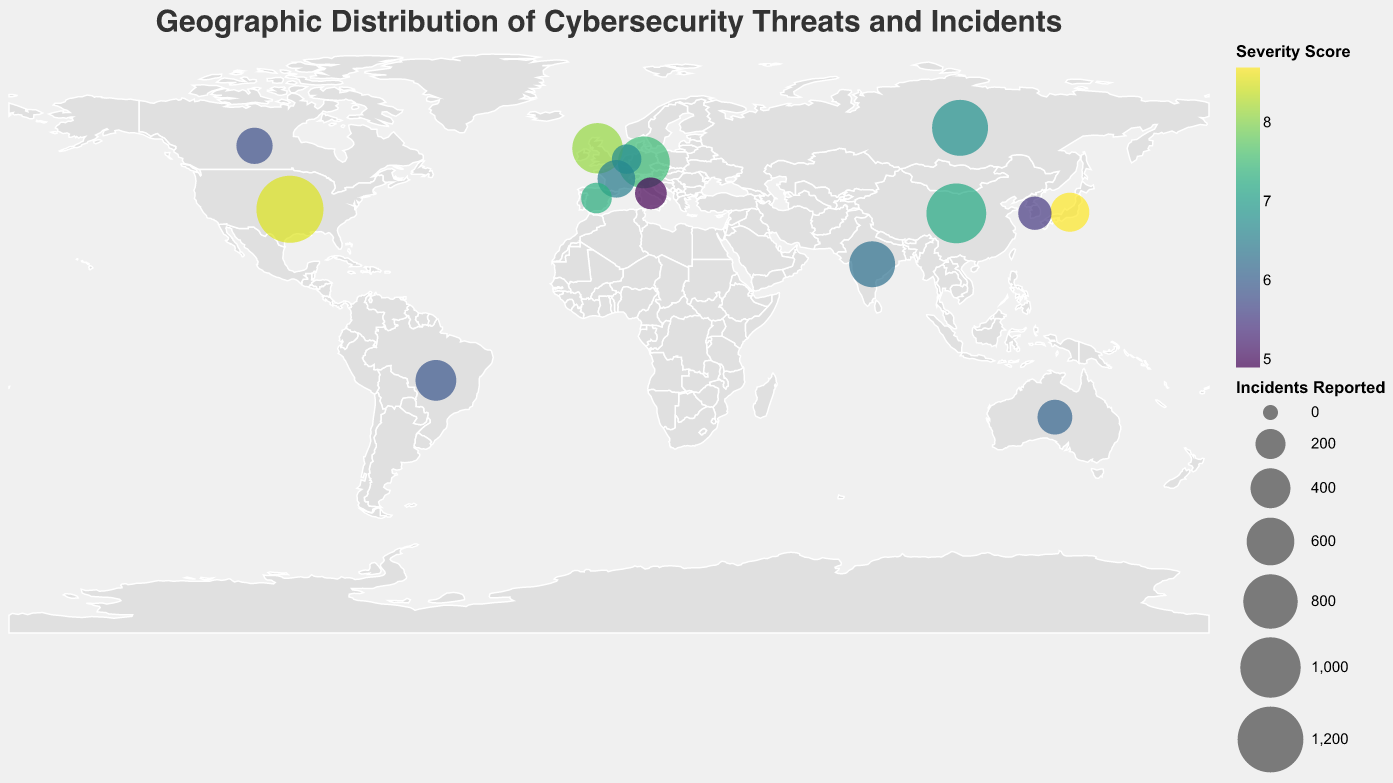What's the highest severity score reported and in which country? The highest severity score can be found by looking at the colors of the circles since the color intensity represents the severity score. The country with a score of 8.7 is Japan.
Answer: Japan with a score of 8.7 Which country has reported the most number of incidents and what type of threat is it associated with? The size of the circles represents the number of incidents reported. The largest circle is situated in the United States, associated with Ransomware and 1250 incidents.
Answer: United States, Ransomware, 1250 incidents How does the severity score of "Insider Threats" in India compare to "IoT Vulnerabilities" in Australia? Compare the color intensity of India (Insider Threats) and Australia (IoT Vulnerabilities). India's score is 6.3 while Australia's is 6.1.
Answer: India's score (6.3) is higher than Australia's score (6.1) What's the total number of incidents reported for all European countries listed? Sum the incidents for Russia (850), Germany (720), United Kingdom (680), France (350), Italy (230), Spain (210), and Netherlands (190). 850 + 720 + 680 + 350 + 230 + 210 + 190 = 3230
Answer: 3230 Which country has the lowest severity score and what threat is it associated with? The lowest severity score can be identified by the lightest colored circle. Italy has the lowest severity score of 4.9, associated with Cryptojacking.
Answer: Italy, Cryptojacking, 4.9 Which country has the smallest circle and what is its threat type? The smallest circle represents the least number of incidents reported. The smallest circle is in the Netherlands, associated with Cloud Security Threats.
Answer: Netherlands, Cloud Security Threats By how much does the number of incidents reported in China exceed those reported in France? Subtract the incidents reported in France (350) from those in China (980). 980 - 350 = 630
Answer: 630 What is the average severity score for incidents reported in South America (Brazil)? Brazil is the only South American country listed with 420 incidents, having a severity score of 5.9.
Answer: 5.9 How many countries have reported incidents related to Phishing and Cryptojacking combined? Identify the countries associated with Phishing and Cryptojacking which are Russia and Italy. Count the countries to get 2.
Answer: 2 